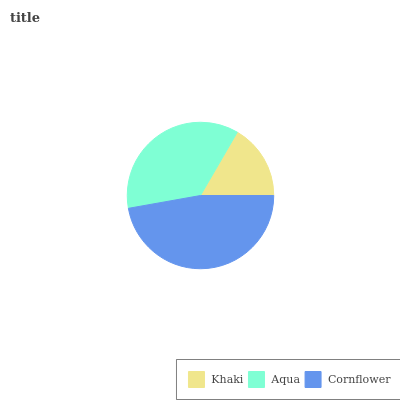Is Khaki the minimum?
Answer yes or no. Yes. Is Cornflower the maximum?
Answer yes or no. Yes. Is Aqua the minimum?
Answer yes or no. No. Is Aqua the maximum?
Answer yes or no. No. Is Aqua greater than Khaki?
Answer yes or no. Yes. Is Khaki less than Aqua?
Answer yes or no. Yes. Is Khaki greater than Aqua?
Answer yes or no. No. Is Aqua less than Khaki?
Answer yes or no. No. Is Aqua the high median?
Answer yes or no. Yes. Is Aqua the low median?
Answer yes or no. Yes. Is Cornflower the high median?
Answer yes or no. No. Is Khaki the low median?
Answer yes or no. No. 